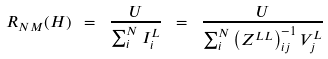Convert formula to latex. <formula><loc_0><loc_0><loc_500><loc_500>R _ { N M } ( H ) \ = \ \frac { U } { \sum _ { i } ^ { N } I ^ { L } _ { i } } \ = \ \frac { U } { \sum _ { i } ^ { N } \left ( Z ^ { L L } \right ) _ { i j } ^ { - 1 } V ^ { L } _ { j } }</formula> 